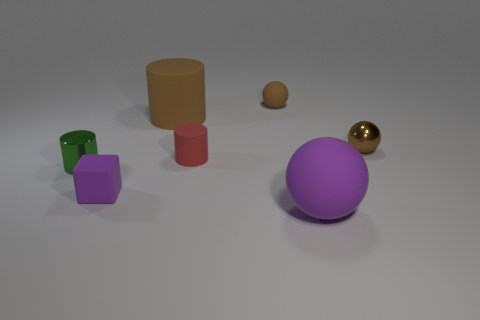What shape is the purple rubber object right of the tiny matte thing on the left side of the big brown matte object?
Keep it short and to the point. Sphere. There is a shiny thing that is the same color as the tiny rubber ball; what is its shape?
Give a very brief answer. Sphere. There is a purple object that is to the right of the small matte cylinder; what is its shape?
Keep it short and to the point. Sphere. There is a rubber sphere that is behind the purple matte ball; what is its size?
Your response must be concise. Small. What material is the large purple sphere?
Give a very brief answer. Rubber. What number of other things are the same material as the small purple cube?
Provide a short and direct response. 4. How many small purple objects are there?
Provide a short and direct response. 1. There is a small green thing that is the same shape as the red object; what is it made of?
Provide a succinct answer. Metal. Is the cylinder behind the tiny matte cylinder made of the same material as the big purple thing?
Keep it short and to the point. Yes. Is the number of tiny metallic things behind the red rubber cylinder greater than the number of tiny brown balls left of the green shiny cylinder?
Offer a very short reply. Yes. 